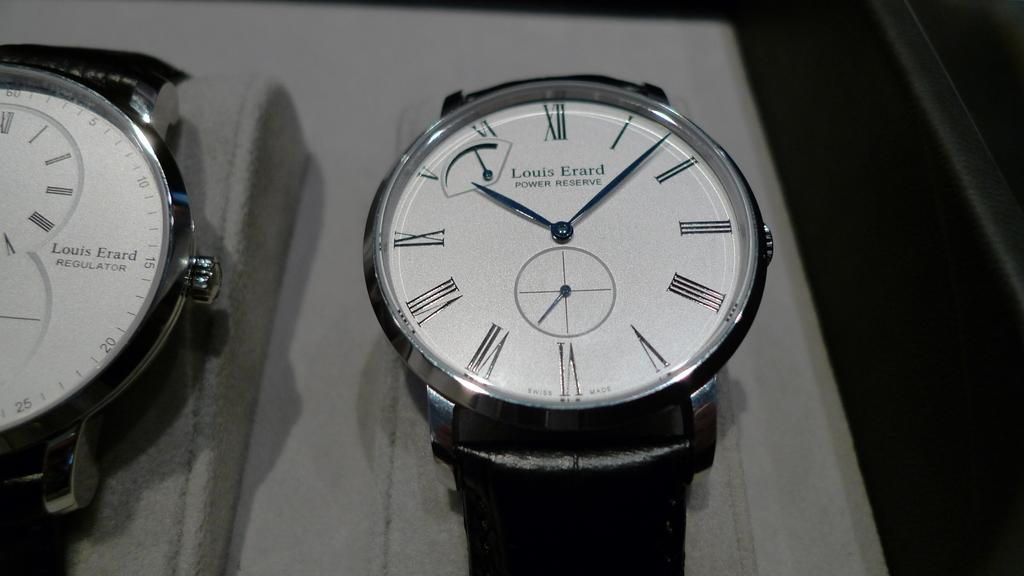<image>
Present a compact description of the photo's key features. Two watches, from the brand Louis Erard, are on display. 